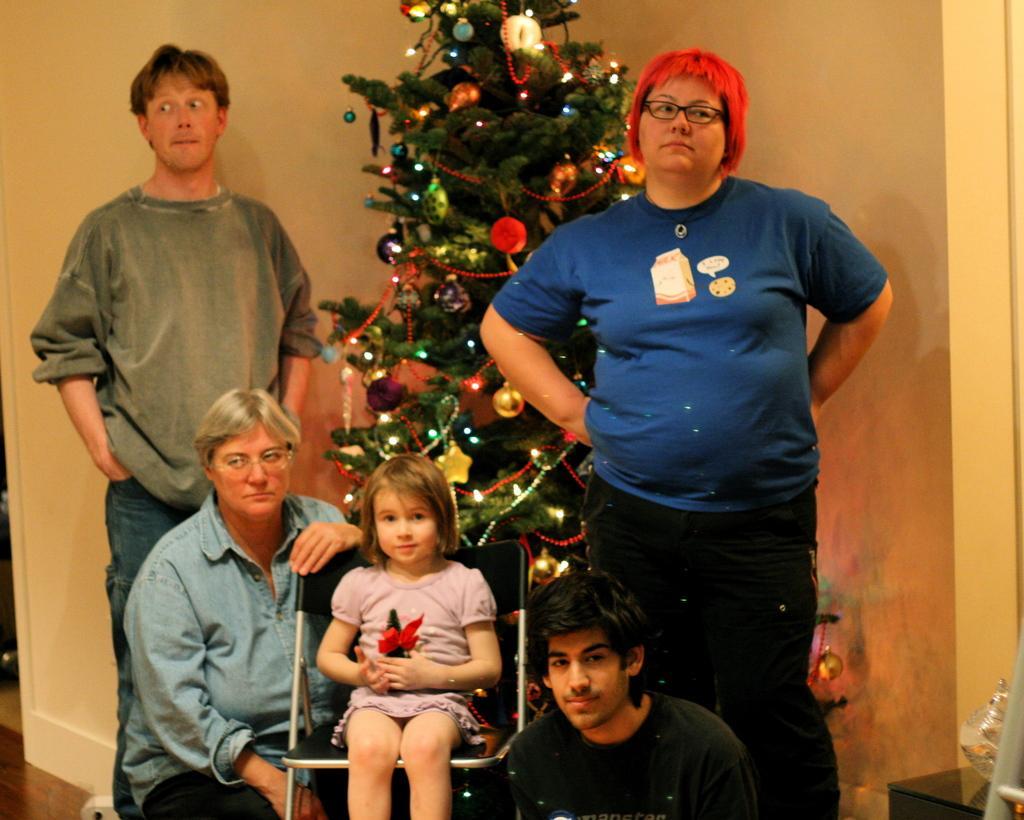Describe this image in one or two sentences. In this picture we can see a group of people, one girl is sitting on a chair, she is holding an object and in the background we can see a wall, Christmas tree and some objects. 